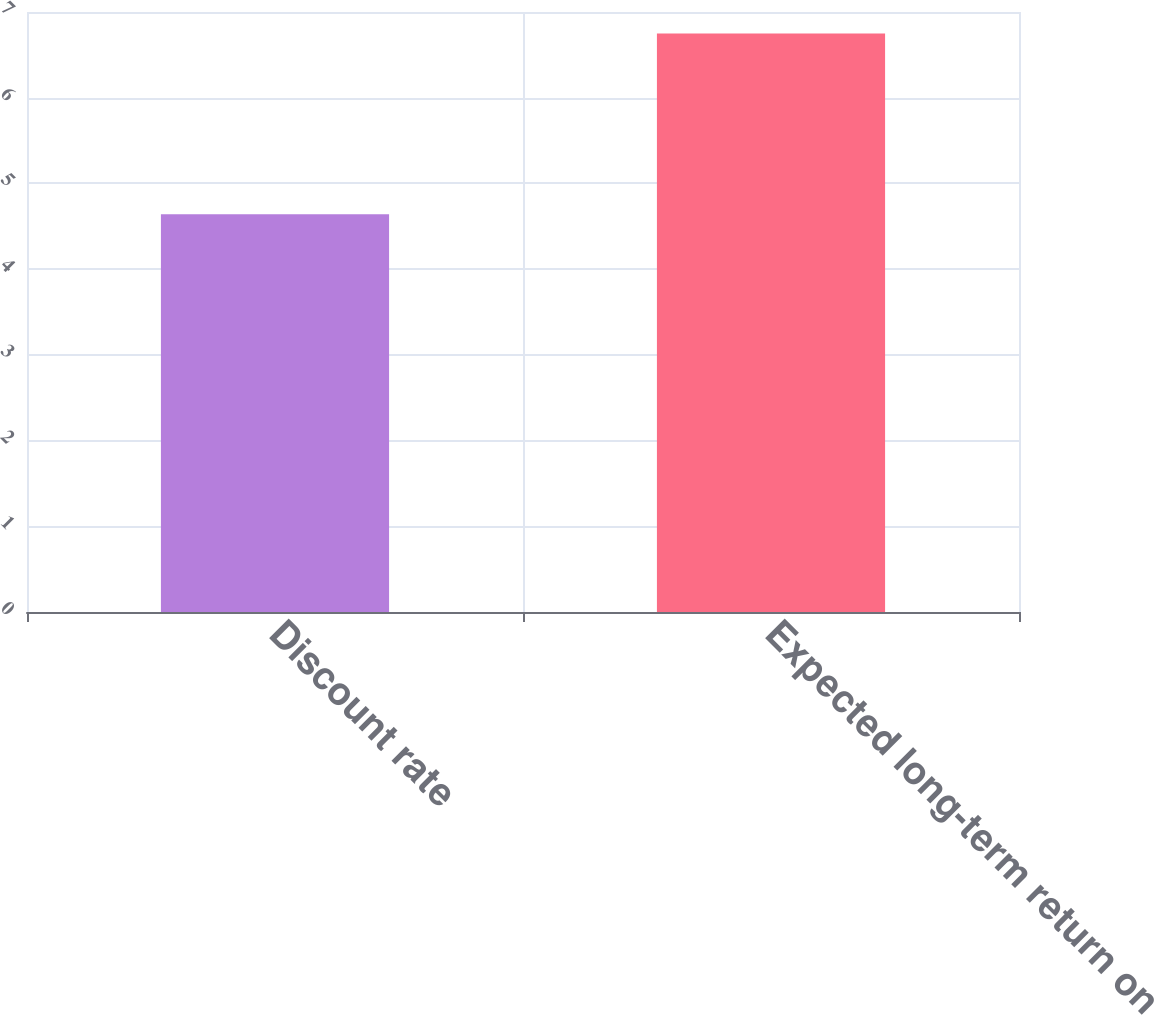Convert chart to OTSL. <chart><loc_0><loc_0><loc_500><loc_500><bar_chart><fcel>Discount rate<fcel>Expected long-term return on<nl><fcel>4.64<fcel>6.75<nl></chart> 